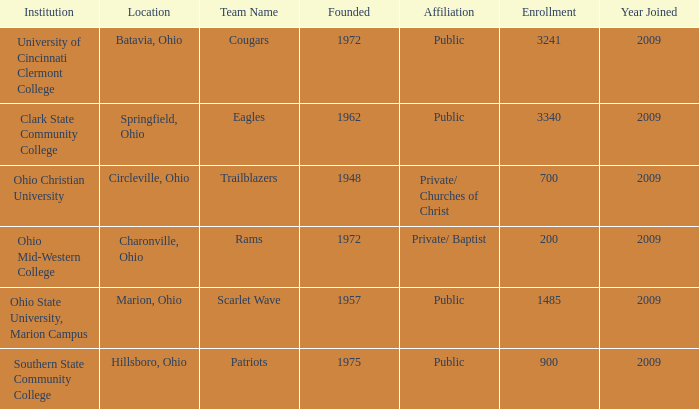How many instances are there for created when the location was springfield, ohio? 1.0. 